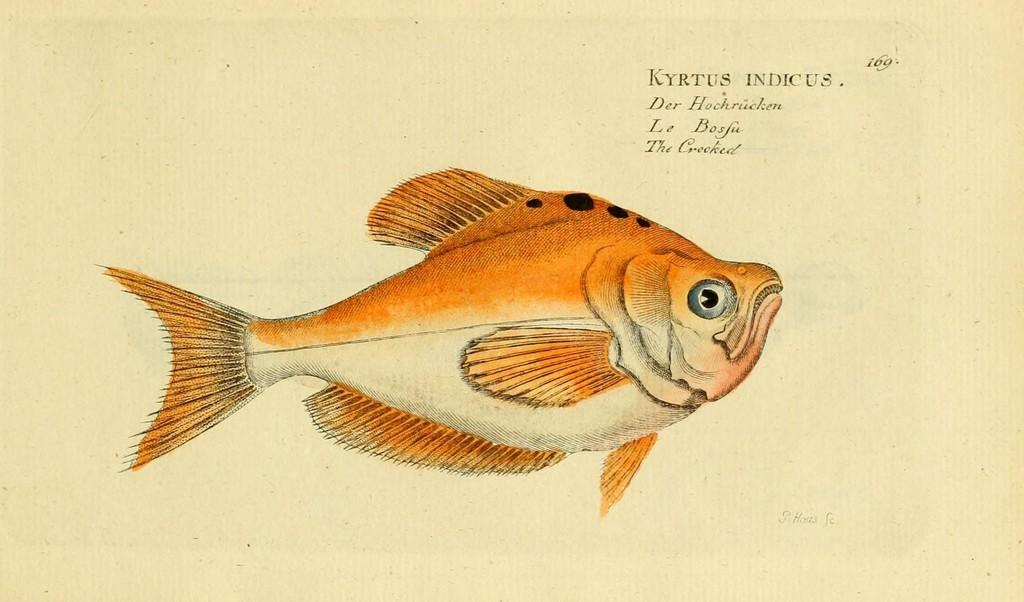What is depicted on the paper in the image? There is a picture of a fish on a paper. What else can be seen in the image besides the picture of the fish? There is text visible in the image. What type of fear does the frog in the image have? There is no frog present in the image; it only a picture of a fish and text are visible. 